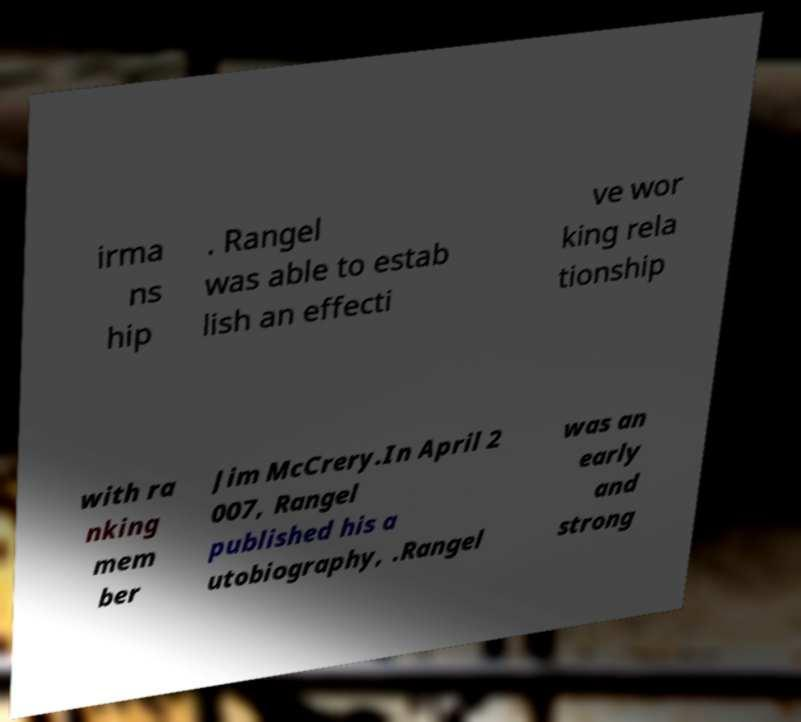Can you read and provide the text displayed in the image?This photo seems to have some interesting text. Can you extract and type it out for me? irma ns hip . Rangel was able to estab lish an effecti ve wor king rela tionship with ra nking mem ber Jim McCrery.In April 2 007, Rangel published his a utobiography, .Rangel was an early and strong 